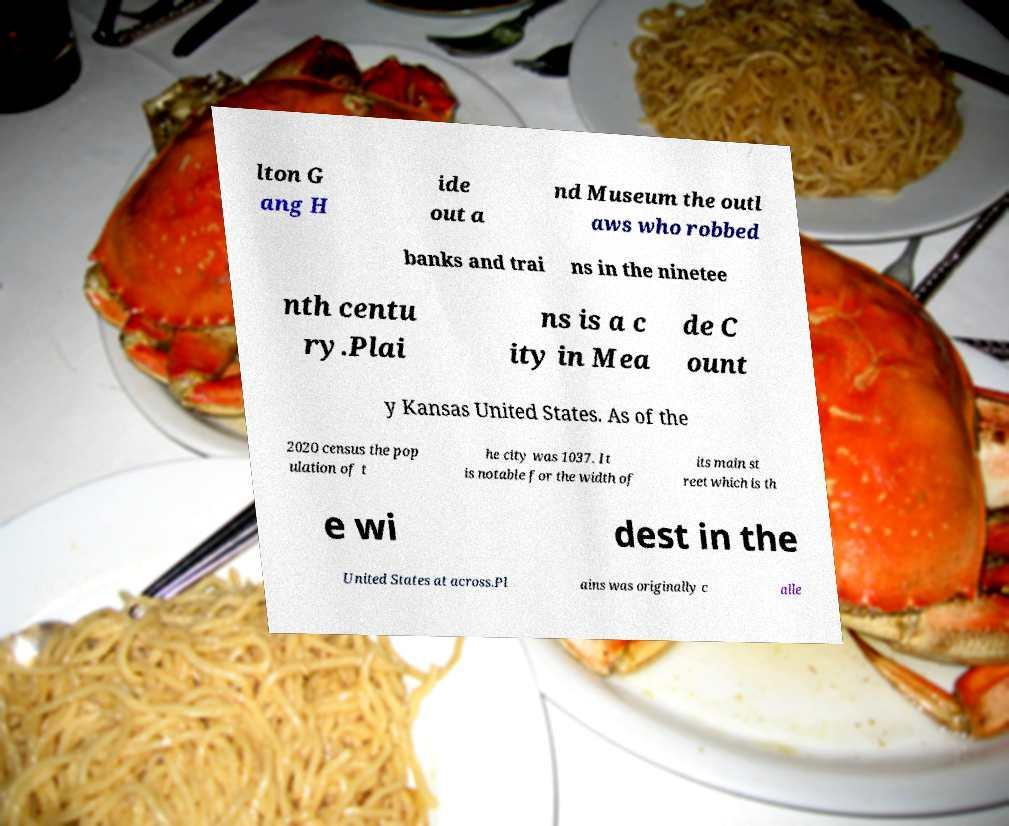Could you extract and type out the text from this image? lton G ang H ide out a nd Museum the outl aws who robbed banks and trai ns in the ninetee nth centu ry.Plai ns is a c ity in Mea de C ount y Kansas United States. As of the 2020 census the pop ulation of t he city was 1037. It is notable for the width of its main st reet which is th e wi dest in the United States at across.Pl ains was originally c alle 